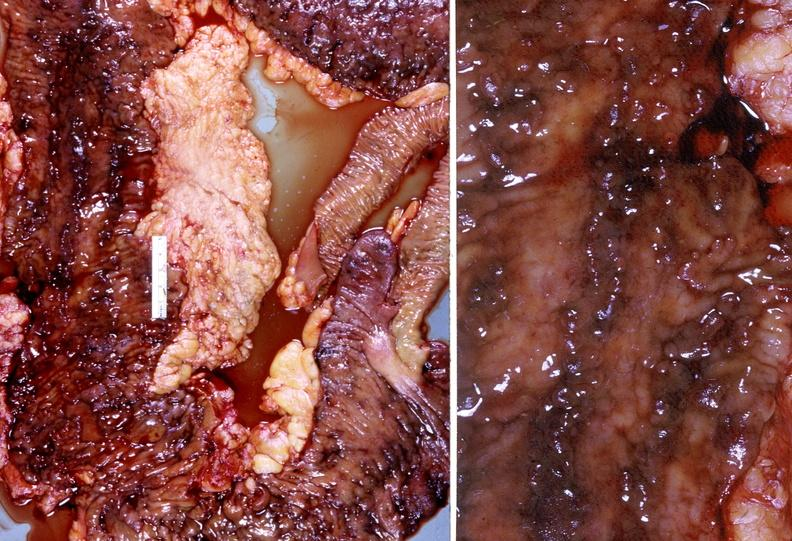does this image show colon, chronic ulcerative colitis?
Answer the question using a single word or phrase. Yes 